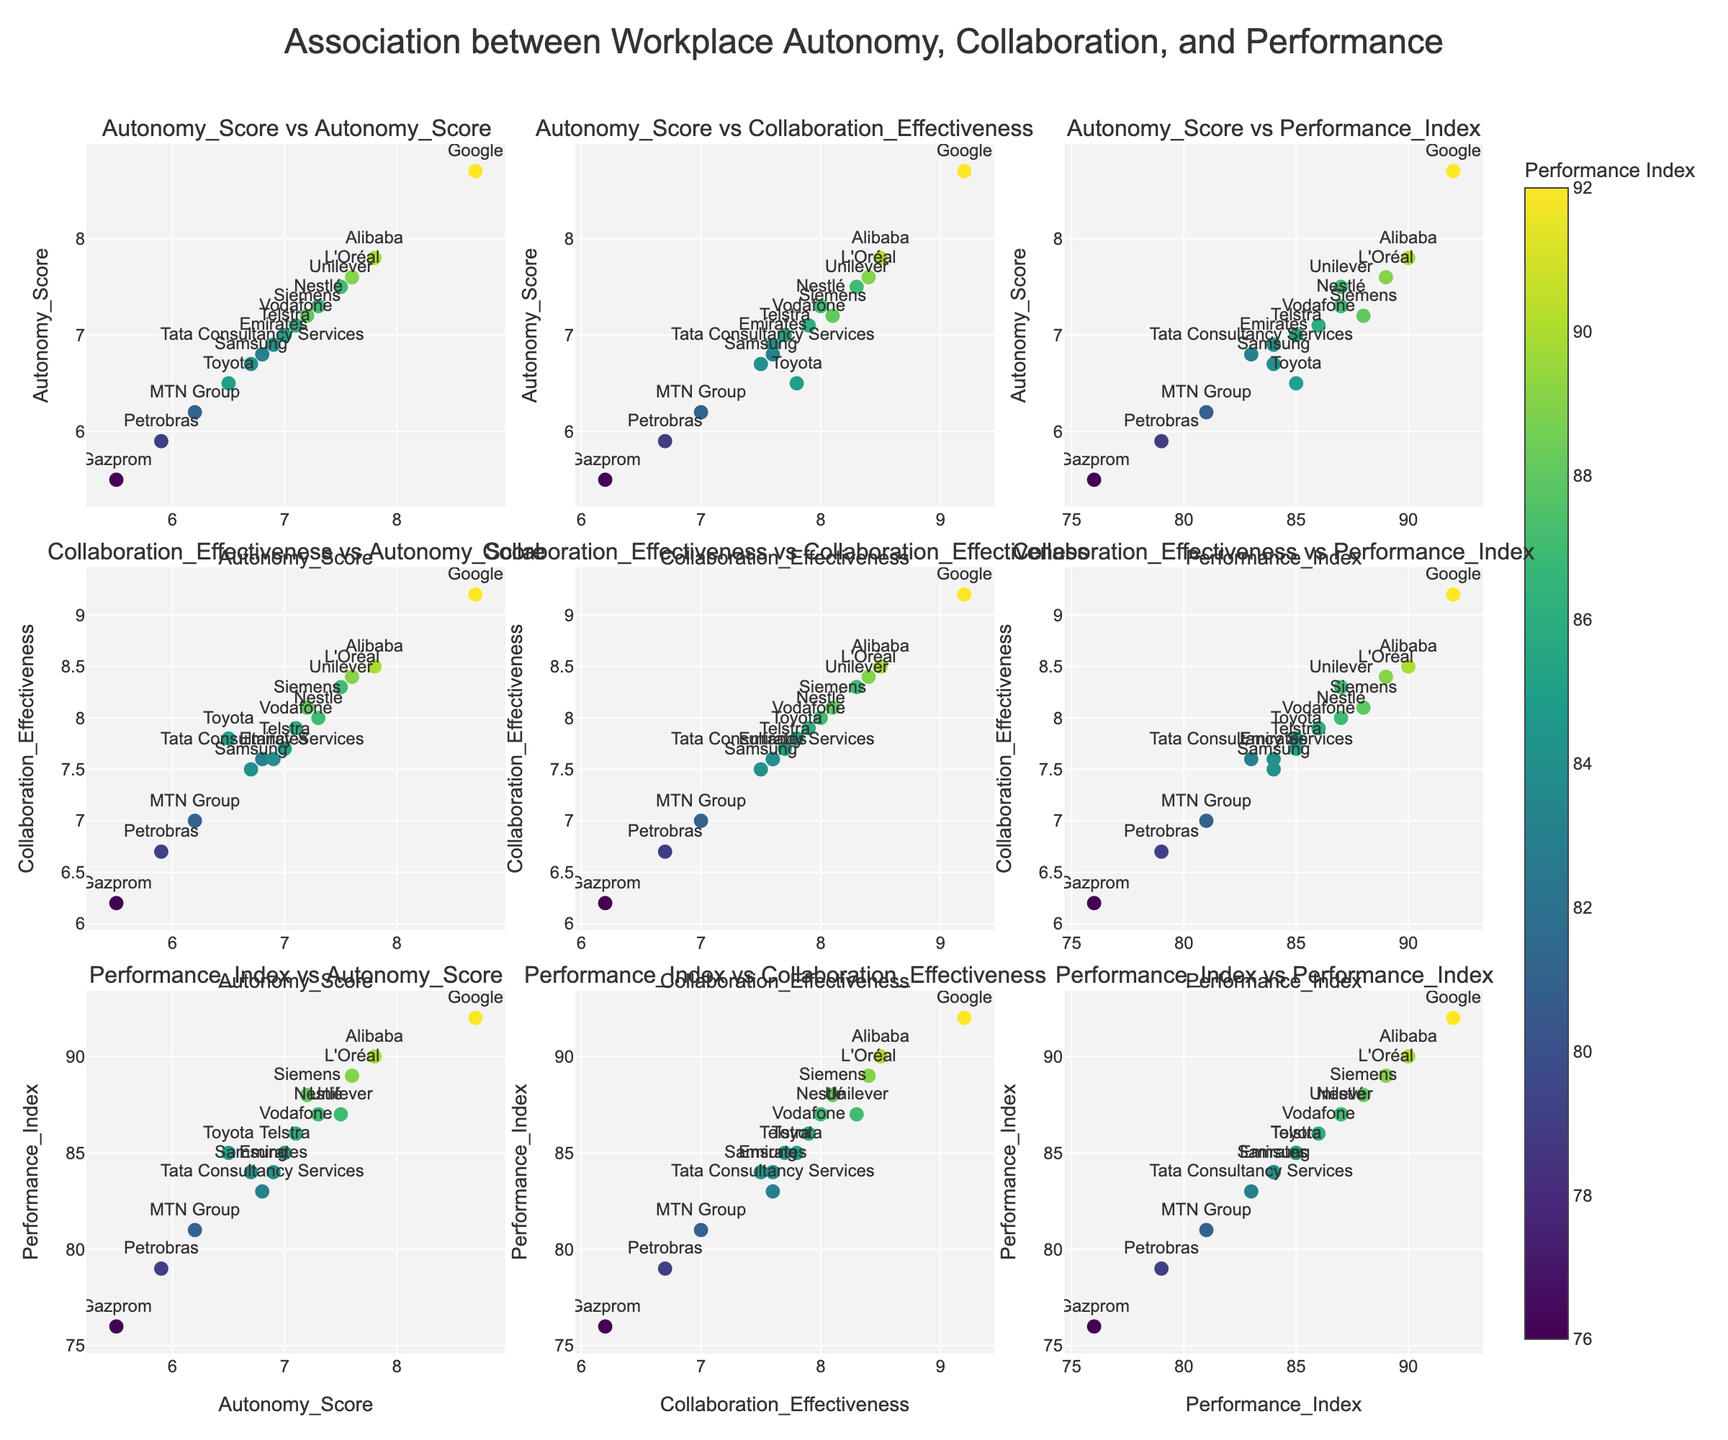What's the title of the figure? The title is at the top of the figure, usually in bigger and bolder font, summarizing the main subject of the plot.
Answer: Association between Workplace Autonomy, Collaboration, and Performance How many companies are displayed in the figure? Count the number of unique data points labeled with company names.
Answer: 15 Which variable has the highest range of values in this plot? Compare the range (difference between maximum and minimum values) for Autonomy Score, Collaboration Effectiveness, and Performance Index by observing the spread of data points across the axes.
Answer: Performance Index How does Google perform in terms of Collaboration Effectiveness compared to Petrobras? Locate the data points for Google and Petrobras and compare their y-coordinates in the Collaboration Effectiveness vs. Performance Index subplot.
Answer: Google's Collaboration Effectiveness is higher than Petrobras Is there a visible cluster of companies with similar performance indices? Look for a grouping of data points with Performance Index values close to each other, indicated by similar colors.
Answer: Yes, most companies have Performance Index values between 80 and 90 What is the relationship between Autonomy Score and Performance Index? Determine if there is a visible trend of increasing or decreasing Performance Index with changes in Autonomy Score by analyzing the corresponding scatter plot cell.
Answer: Generally positive Which cultural context shows the highest performance index? Identify the data point with the highest Performance Index and check its corresponding Cultural Context.
Answer: United States (Google) Which company has the lowest Autonomy Score, and how does it relate to its Performance Index? Find the data point with the lowest value on the Autonomy Score axis and observe its position on the Performance Index axis.
Answer: Gazprom, with a relatively low Performance Index (76) What is the average Collaboration Effectiveness of all companies displayed? Sum all the Collaboration Effectiveness scores and divide by the number of companies (15). (9.2+7.8+8.1+8.5+8.3+7.6+7.9+6.7+7.5+8.4+6.2+8.0+7.7+7.0+7.6)/15
Answer: 7.77 Are there any companies that score high in both Autonomy and Collaboration but have a lower Performance Index? Look for data points that are high on both the Autonomy Score and Collaboration Effectiveness axes yet lower on the Performance Index scale (indicated by color).
Answer: No 